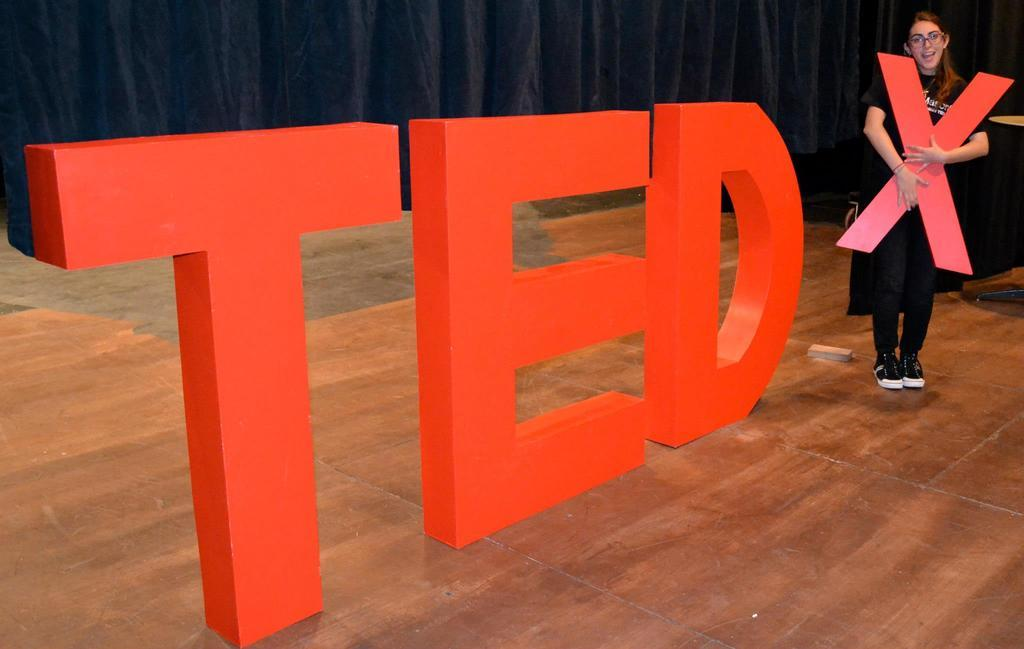What is on the stage in the image? There are Tedx cutouts on the stage. What is the woman holding in the image? The woman is holding a cutout of the letter X. What can be seen in the background of the image? There is a black curtain in the background. How many rabbits are present on the stage in the image? There are no rabbits present on the stage in the image. What role does the father play in the Tedx event in the image? There is no mention of a father or any specific roles in the image. 